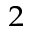<formula> <loc_0><loc_0><loc_500><loc_500>^ { 2 }</formula> 